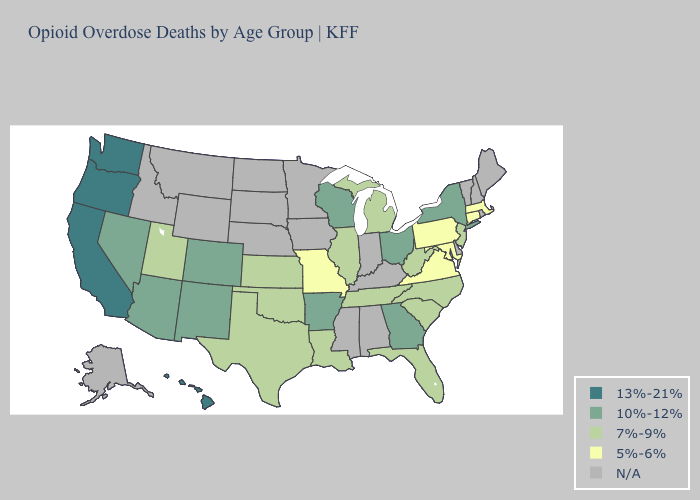Name the states that have a value in the range 13%-21%?
Give a very brief answer. California, Hawaii, Oregon, Washington. Among the states that border Colorado , which have the lowest value?
Give a very brief answer. Kansas, Oklahoma, Utah. Among the states that border Pennsylvania , does Ohio have the highest value?
Write a very short answer. Yes. Name the states that have a value in the range 7%-9%?
Short answer required. Florida, Illinois, Kansas, Louisiana, Michigan, New Jersey, North Carolina, Oklahoma, South Carolina, Tennessee, Texas, Utah, West Virginia. Among the states that border California , which have the lowest value?
Be succinct. Arizona, Nevada. What is the lowest value in states that border Indiana?
Short answer required. 7%-9%. Does Tennessee have the lowest value in the South?
Give a very brief answer. No. What is the highest value in the Northeast ?
Write a very short answer. 10%-12%. Which states have the lowest value in the MidWest?
Write a very short answer. Missouri. Does Arkansas have the highest value in the South?
Be succinct. Yes. Which states have the highest value in the USA?
Write a very short answer. California, Hawaii, Oregon, Washington. Does California have the highest value in the USA?
Quick response, please. Yes. Does North Carolina have the highest value in the South?
Quick response, please. No. Name the states that have a value in the range 5%-6%?
Quick response, please. Connecticut, Maryland, Massachusetts, Missouri, Pennsylvania, Virginia. 